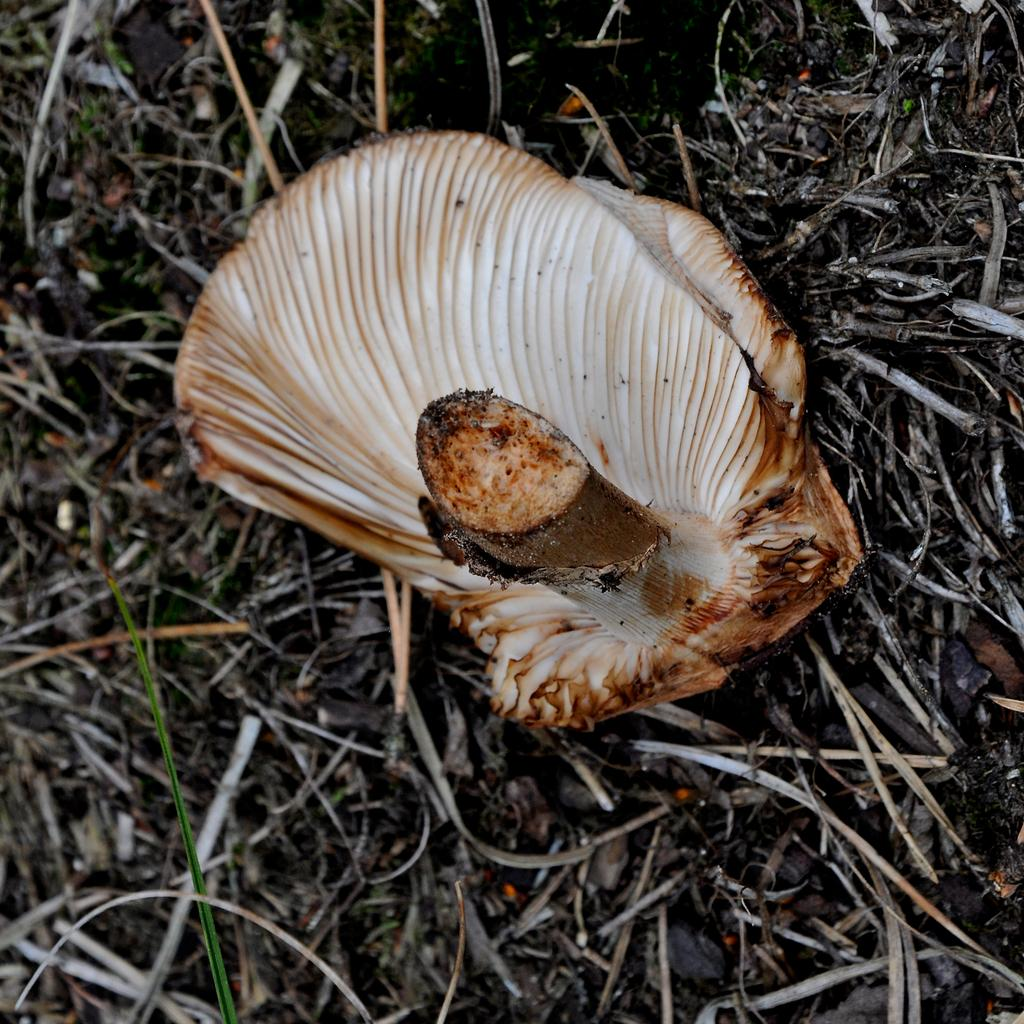What is the main subject of the image? The main subject of the image is a mushroom. Can you describe the color of the mushroom? The mushroom is white in color. Where is the mushroom located in the image? The mushroom is on the ground. What type of flowers can be seen growing around the mushroom in the image? There are no flowers present in the image; it only features a white mushroom on the ground. 